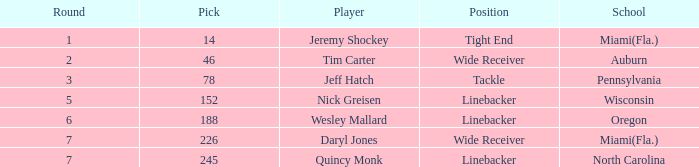From what school was the linebacker that had a pick less than 245 and was drafted in round 6? Oregon. 